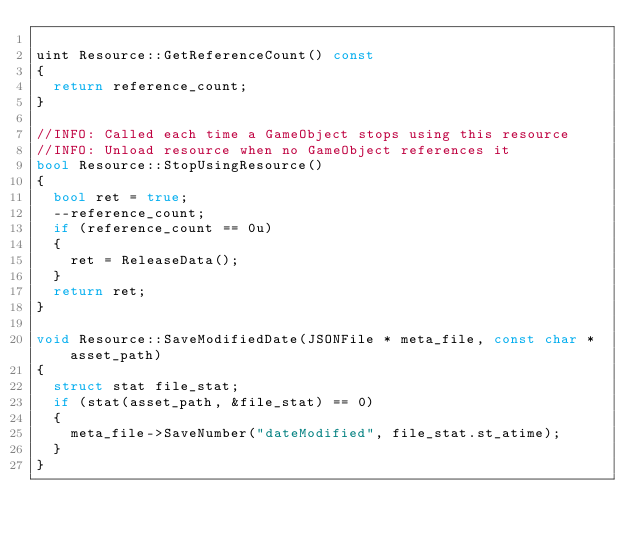Convert code to text. <code><loc_0><loc_0><loc_500><loc_500><_C++_>
uint Resource::GetReferenceCount() const
{
	return reference_count;
}

//INFO: Called each time a GameObject stops using this resource
//INFO: Unload resource when no GameObject references it
bool Resource::StopUsingResource()
{
	bool ret = true;
	--reference_count;
	if (reference_count == 0u)
	{
		ret = ReleaseData();
	}
	return ret;
}

void Resource::SaveModifiedDate(JSONFile * meta_file, const char * asset_path)
{
	struct stat file_stat;
	if (stat(asset_path, &file_stat) == 0)
	{
		meta_file->SaveNumber("dateModified", file_stat.st_atime);
	}
}</code> 